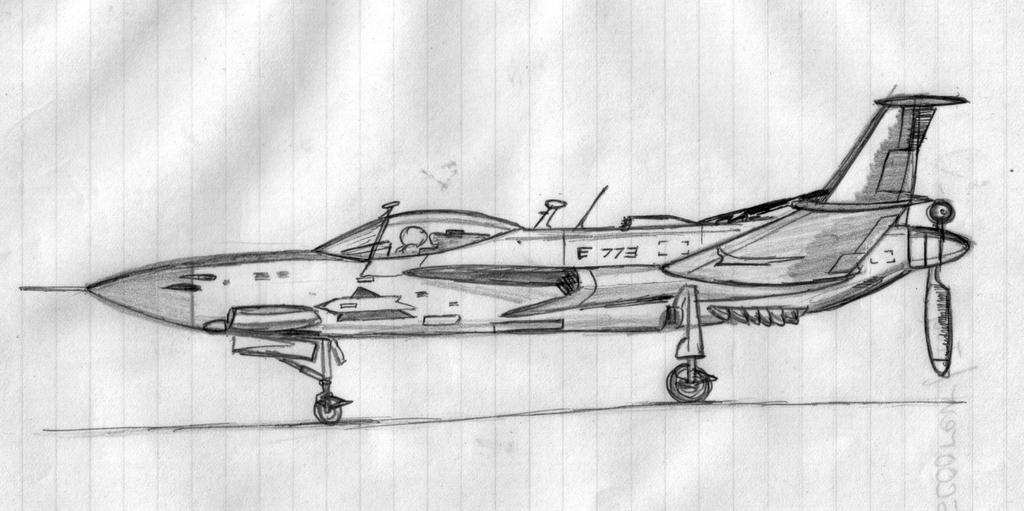How would you summarize this image in a sentence or two? In this picture I can see the drawing of a jet plane in a paper. 